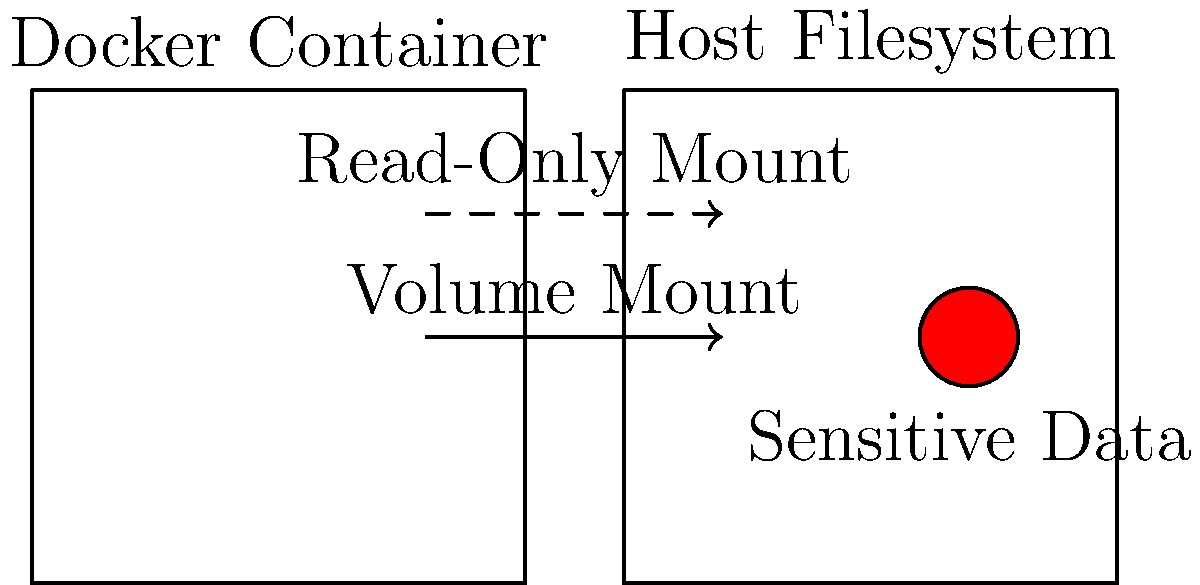Which Docker volume mounting strategy provides better security when dealing with sensitive data on the host filesystem? To determine the most secure Docker volume mounting strategy for sensitive data, let's consider the following steps:

1. Understand the two main volume mounting options:
   a) Read-write mount: Allows the container to read and modify data
   b) Read-only mount: Allows the container to only read data

2. Consider the security implications:
   a) Read-write mounts give containers full access to modify host data
   b) Read-only mounts restrict containers from modifying host data

3. Evaluate the principle of least privilege:
   - This principle suggests granting only the minimum necessary permissions

4. Analyze the risk of potential container compromises:
   - If a container is compromised with a read-write mount, an attacker could modify or delete sensitive data
   - With a read-only mount, the attacker's ability to manipulate data is limited

5. Consider data integrity:
   - Read-only mounts help maintain data integrity by preventing accidental or malicious modifications

6. Examine use cases:
   - Most scenarios involving sensitive data require read access only (e.g., configuration files, SSL certificates)
   - Write access is rarely needed for sensitive data from within containers

7. Conclude based on security best practices:
   - Read-only mounts provide a higher level of security by restricting write access to sensitive data

Therefore, the read-only volume mounting strategy is more secure when dealing with sensitive data on the host filesystem.
Answer: Read-only volume mounting 